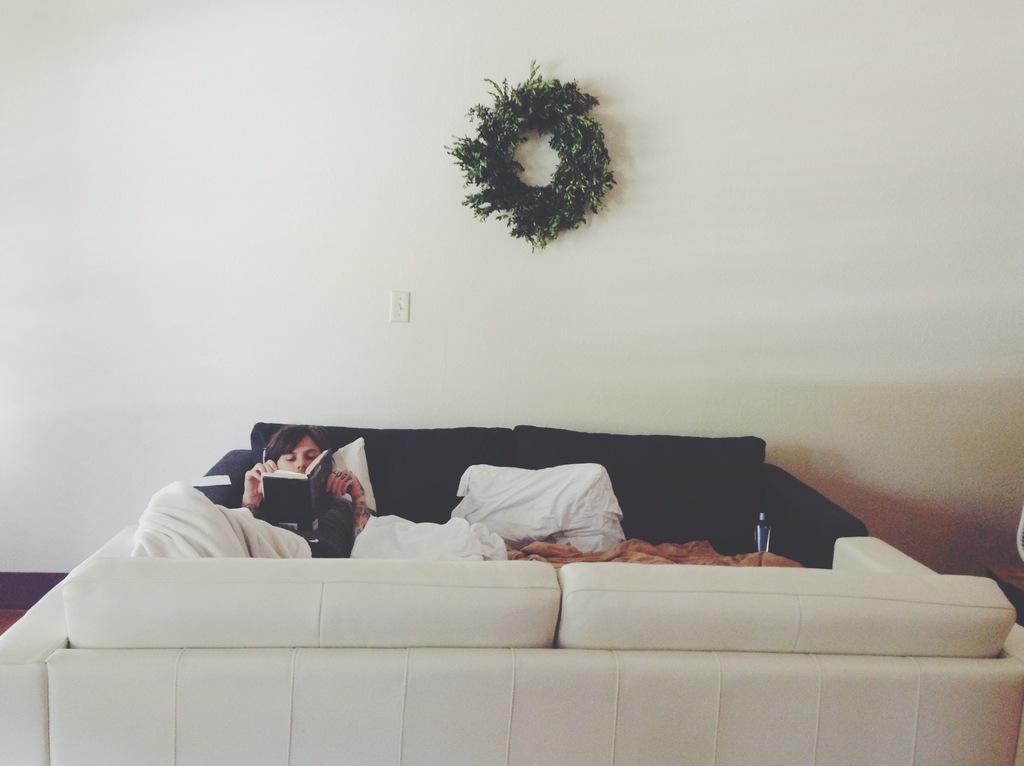Could you give a brief overview of what you see in this image? He is lying on bed. His reading book. We can see the background is wall and decoration plant. 